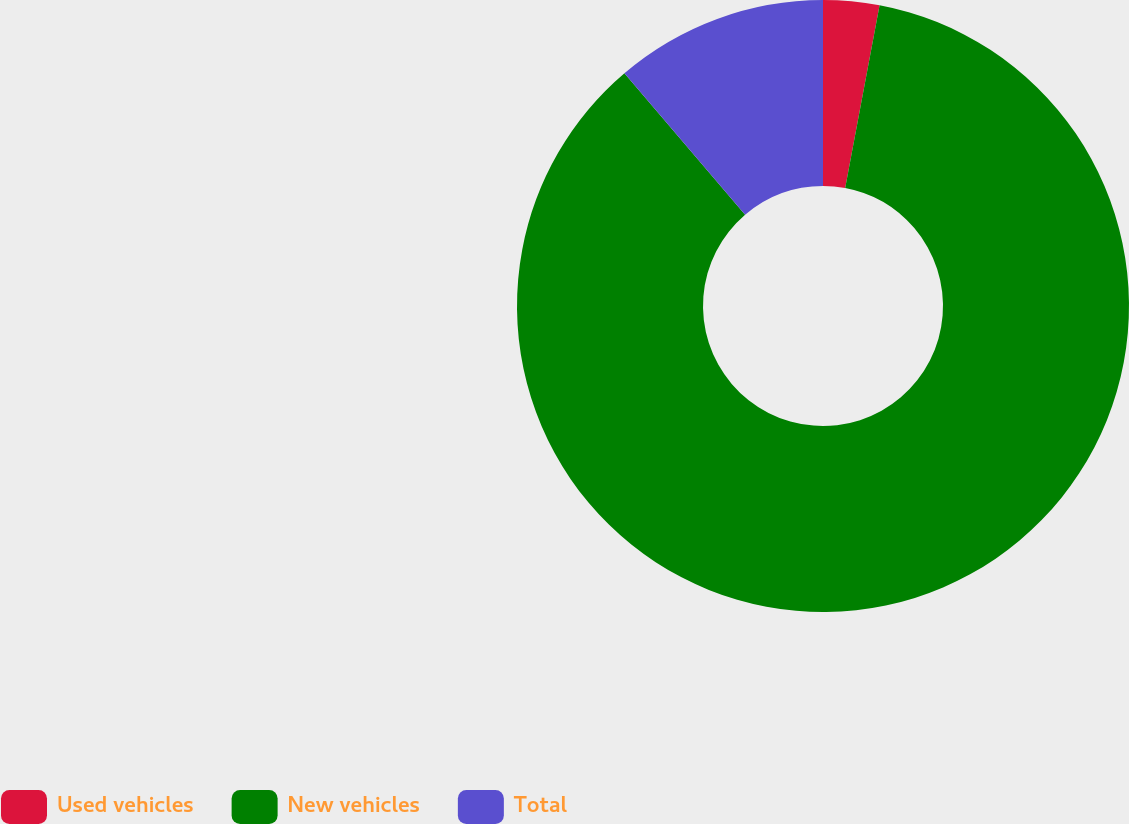<chart> <loc_0><loc_0><loc_500><loc_500><pie_chart><fcel>Used vehicles<fcel>New vehicles<fcel>Total<nl><fcel>2.96%<fcel>85.8%<fcel>11.24%<nl></chart> 